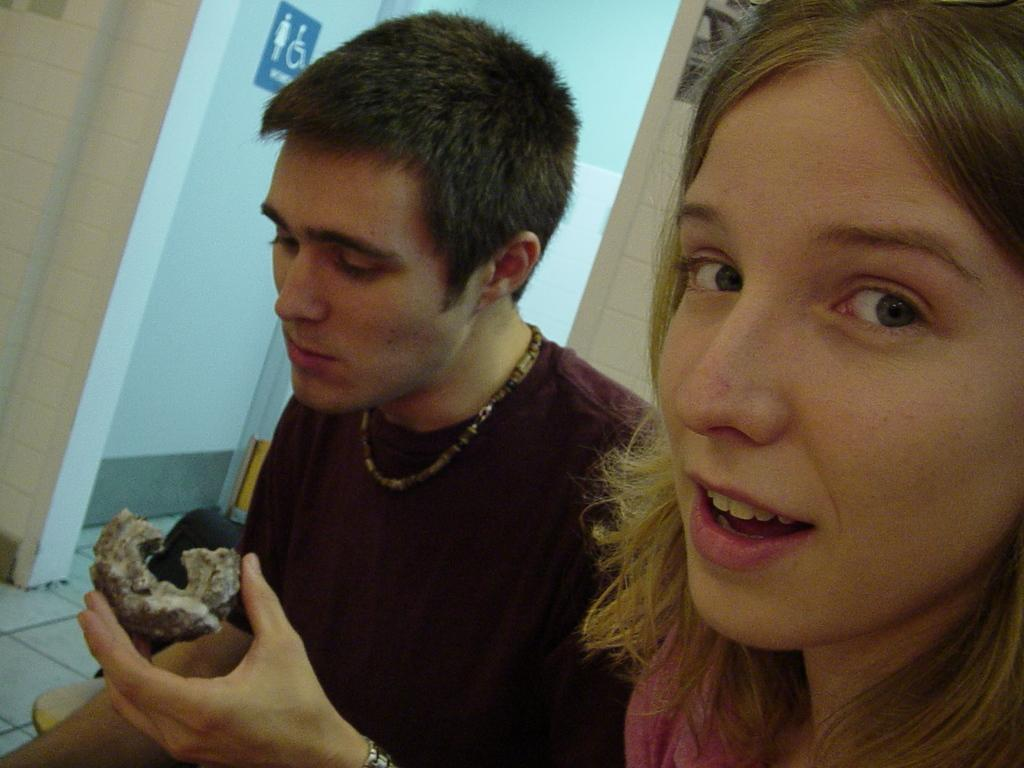How many people are in the image? There are two persons in the image. Can you describe the positions of the people in the image? A man is on the left side of the image, and a woman is on the right side of the image. What is the man holding in his hand? The man is holding something in his hand, but the image does not provide enough detail to determine what it is. What can be seen in the background of the image? There is a wall in the background of the image. What type of cream is being applied to the woman's hair in the image? There is no cream being applied to the woman's hair in the image. 